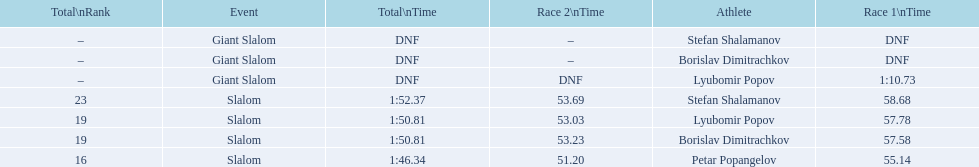What is the number of athletes to finish race one in the giant slalom? 1. 